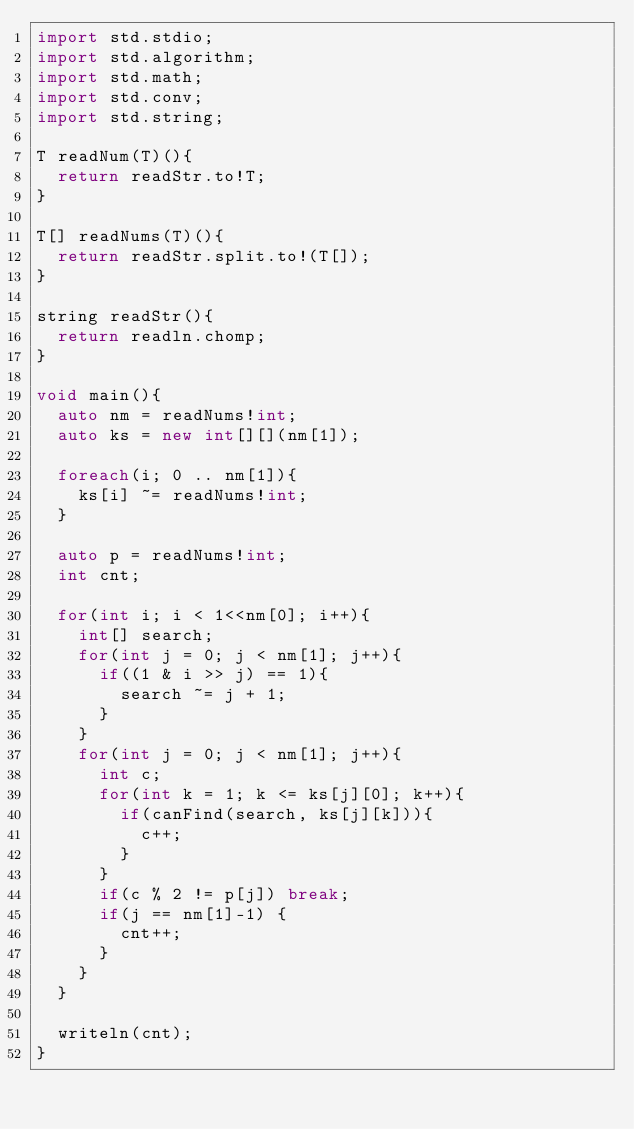Convert code to text. <code><loc_0><loc_0><loc_500><loc_500><_D_>import std.stdio;
import std.algorithm;
import std.math;
import std.conv;
import std.string;

T readNum(T)(){
  return readStr.to!T;
}

T[] readNums(T)(){
  return readStr.split.to!(T[]);
}

string readStr(){
  return readln.chomp;
}

void main(){
  auto nm = readNums!int;
  auto ks = new int[][](nm[1]);

  foreach(i; 0 .. nm[1]){
    ks[i] ~= readNums!int;
  }

  auto p = readNums!int;
  int cnt;

  for(int i; i < 1<<nm[0]; i++){
    int[] search;
    for(int j = 0; j < nm[1]; j++){
      if((1 & i >> j) == 1){
        search ~= j + 1;
      }
    }
    for(int j = 0; j < nm[1]; j++){
      int c;
      for(int k = 1; k <= ks[j][0]; k++){
        if(canFind(search, ks[j][k])){
          c++;
        }
      }
      if(c % 2 != p[j]) break;
      if(j == nm[1]-1) {
        cnt++;
      }
    }
  }

  writeln(cnt);
}
</code> 